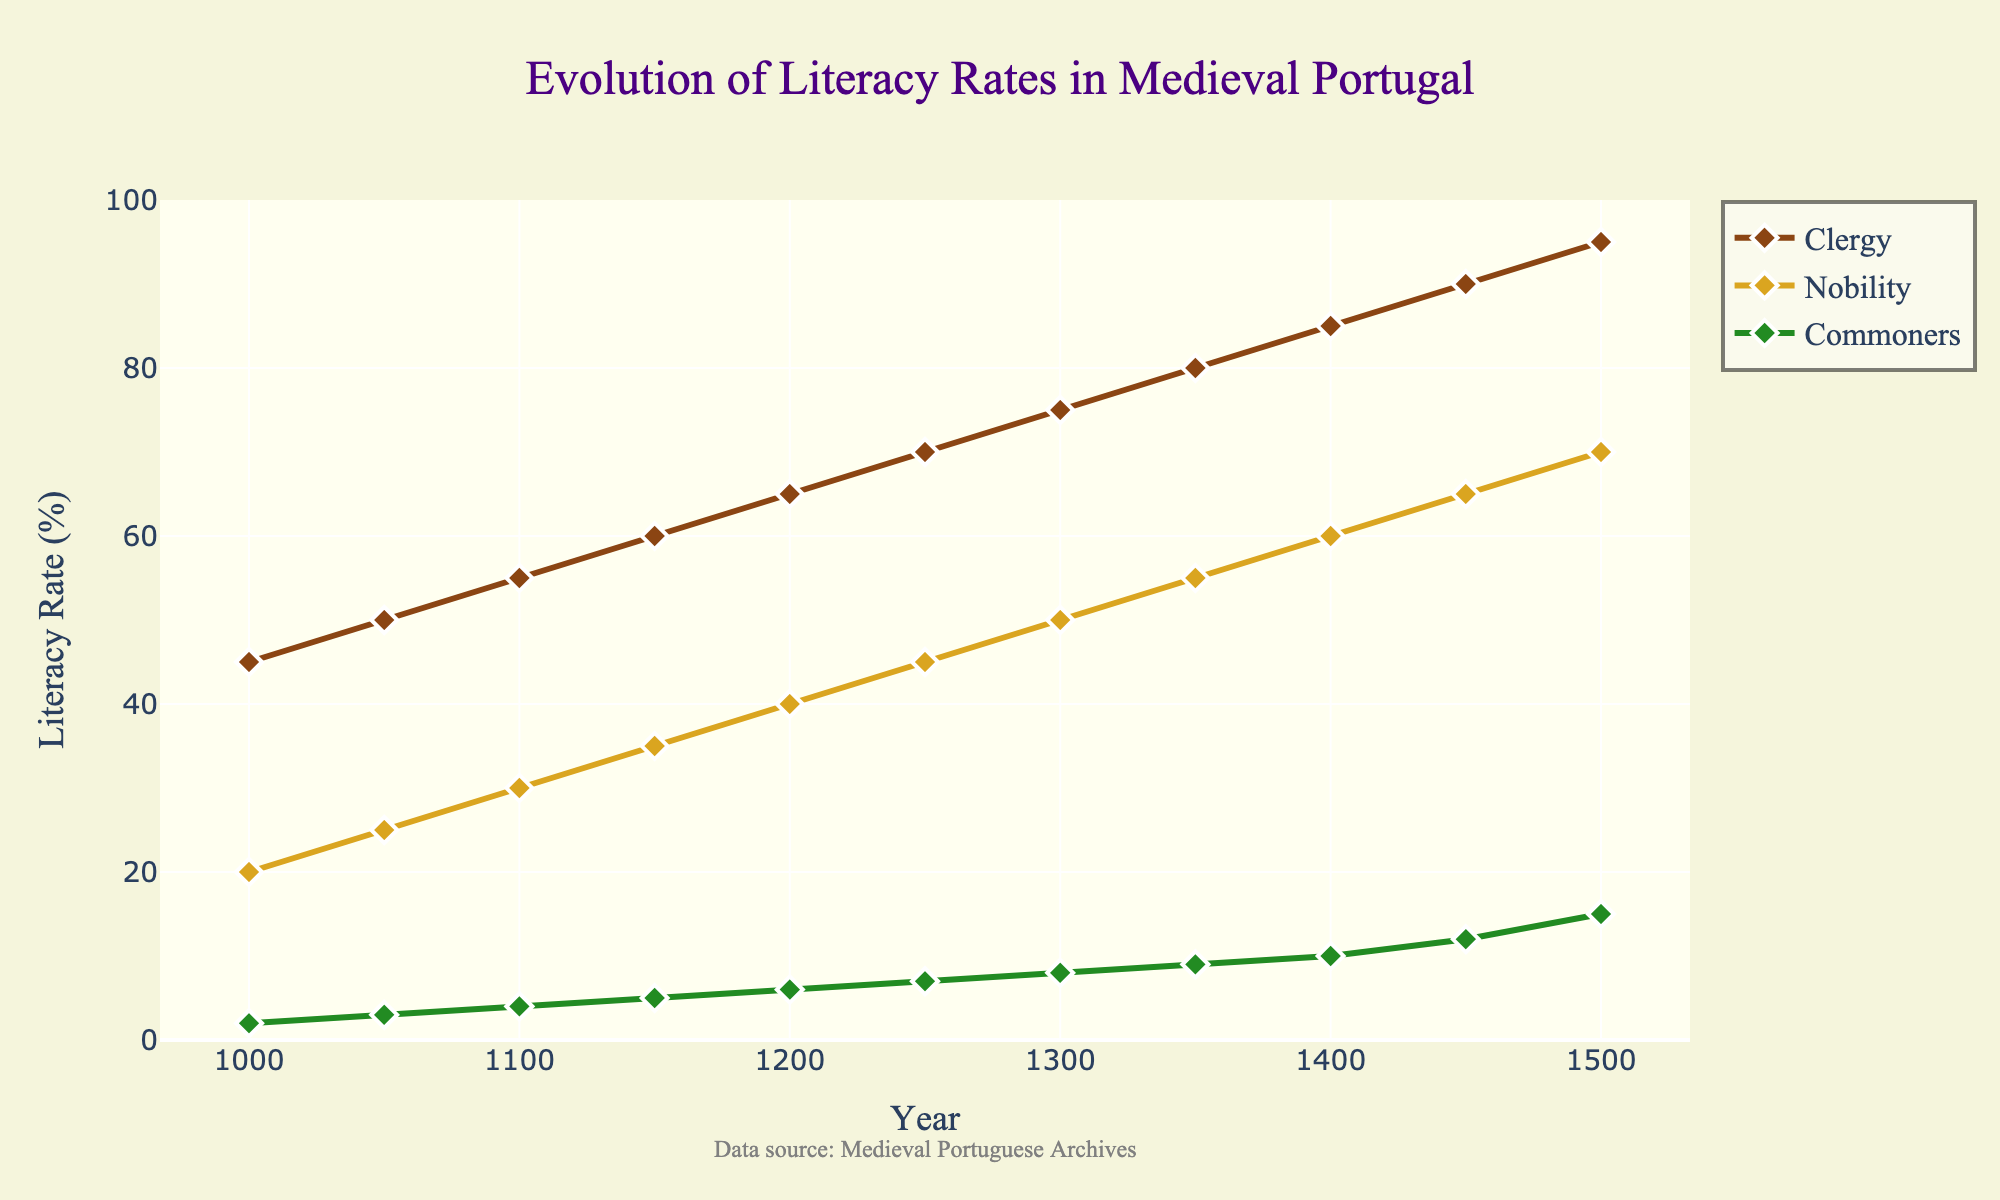What's the overall trend in literacy rates among all three groups from 1000 to 1500? By examining the lines for the clergy, nobility, and commoners, it’s evident that literacy rates for all three groups show an increasing trend over time. Each group’s literacy rate continuously increases from 1000 to 1500.
Answer: Increasing Which group had the highest literacy rate in the year 1300? In the figure, the data point for the year 1300 shows that the Clergy had the literacy rate of 75%, which is higher than both the Nobility (50%) and the Commoners (8%).
Answer: Clergy By how much did the literacy rate among commoners increase from 1200 to 1450? The literacy rate among commoners was 6% in 1200 and increased to 12% in 1450. The difference between these values is 12% - 6% = 6%.
Answer: 6% Compare the growth in literacy rates between the nobility and the commoners from 1000 to 1500. Which group saw a larger absolute increase? For the Nobility, the literacy rate went from 20% to 70%, an increase of 50%. For the Commoners, it went from 2% to 15%, an increase of 13%. The Nobility saw a larger absolute increase.
Answer: Nobility What is the average literacy rate for the Clergy over the depicted period? To calculate the average literacy rate for the Clergy: (45 + 50 + 55 + 60 + 65 + 70 + 75 + 80 + 85 + 90 + 95) / 11, which equals 770 / 11 = ~70%.
Answer: 70% Which group had the slowest growth in literacy rates from 1400 to 1450? In the figure, the literacy rates from 1400 to 1450 change as follows: Clergy: 85%-90% (+5%), Nobility: 60%-65% (+5%), Commoners: 10%-12% (+2%). Hence, Commoners had the slowest growth.
Answer: Commoners How does the color used for each group in the plot aid in distinguishing the trends? The colors used (Brown for Clergy, Goldenrod for Nobility, Forest Green for Commoners) are distinct and help in visually separating each group's line, making it easier to follow their respective trends.
Answer: Distinct colors What was the literacy rate of the nobility compared to the clergy in 1150? In the year 1150, the Clergy had a literacy rate of 60%, while the Nobility had a literacy rate of 35%. The Clergy’s literacy rate was higher than that of the Nobility.
Answer: Clergy higher By what factor did the literacy rate among commoners increase from 1000 to 1500? To find the factor of the increase for the Commoners: the literacy rate grew from 2% to 15%. The factor is 15 / 2 = 7.5.
Answer: 7.5 What visual cues help identify the decades where significant shifts in literacy rates occurred? The markers on the line plots (diamonds at each data point) and the steepness of the lines indicate significant shifts. For example, steep increases are visually identifiable in the second half of the given time frame, especially for the Clergy and Nobility.
Answer: Markers and steepness 